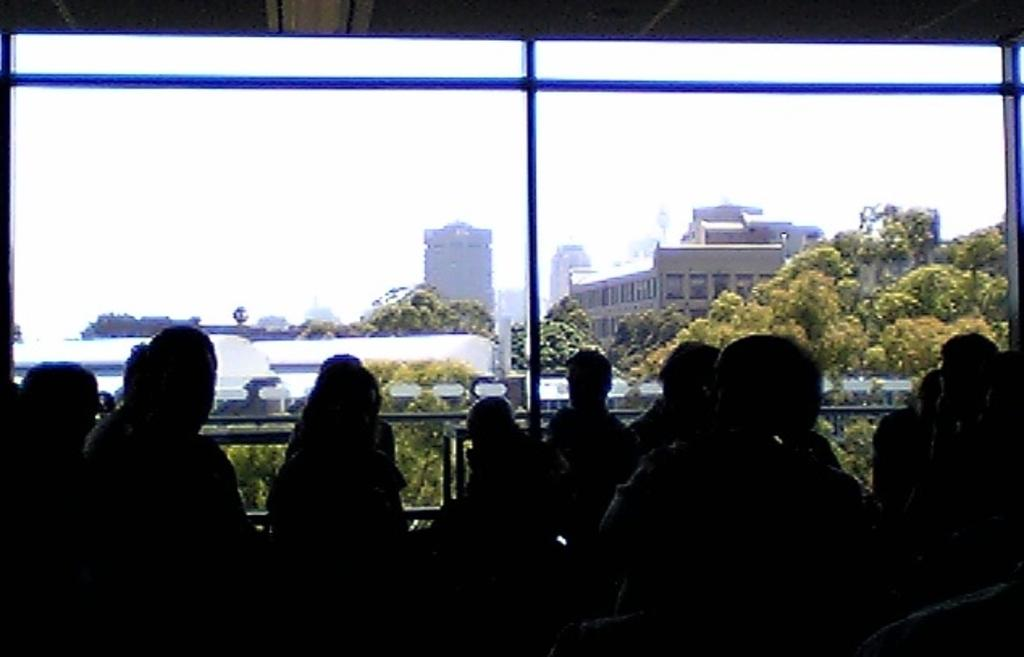Who or what is present in the image? There are people in the image. What is the main feature of the background in the image? There is a glass wall in the image, through which trees and buildings are visible. What can be seen in the sky in the image? The sky is visible at the top of the image. How does the glass wall support the wave in the image? There is no wave present in the image, and the glass wall is not supporting any wave. 